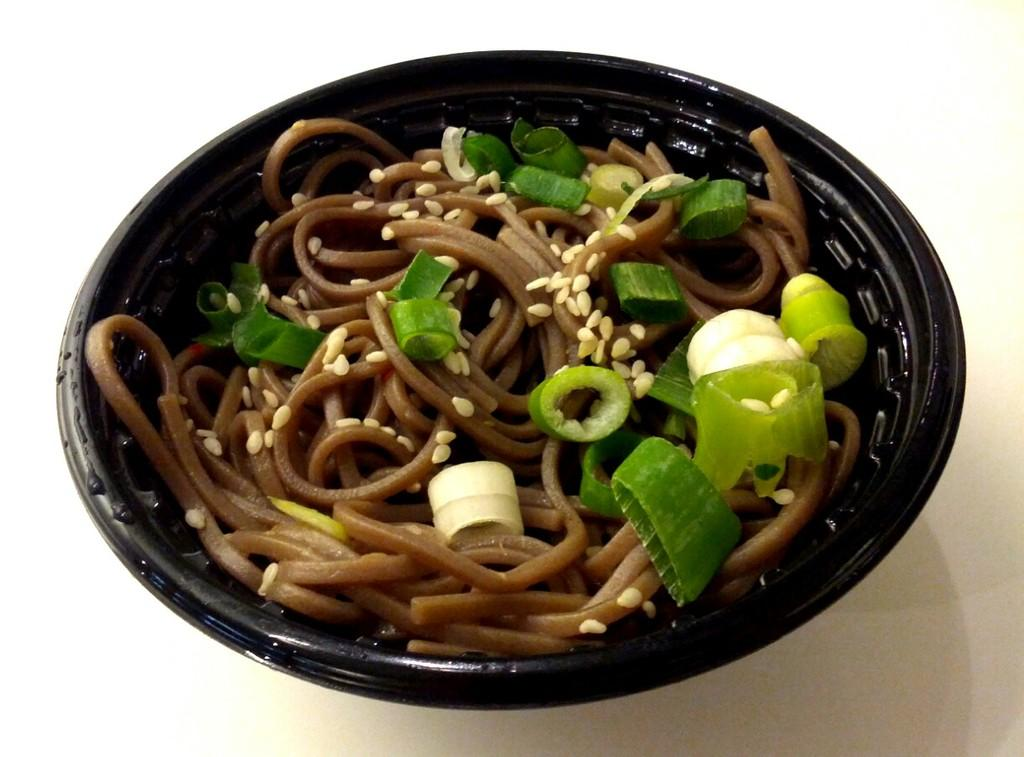What is in the bowl that is visible in the image? There is food in a bowl in the image. Where is the bowl located in the image? The bowl is on a white platform. What type of account does the food in the bowl have in the image? The food in the bowl does not have an account in the image, as it is not a sentient being capable of having an account. Can you tell me how many divisions are visible in the image? There is no division present in the image; it features a bowl of food on a white platform. 